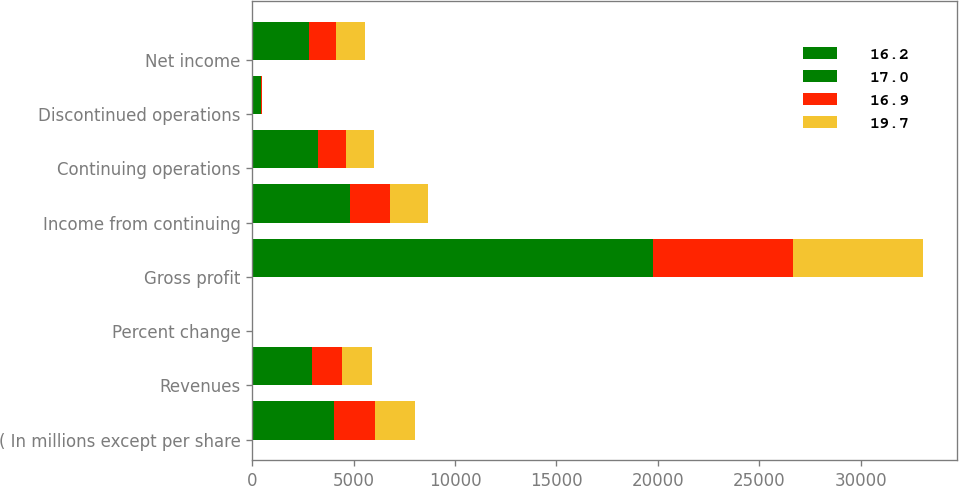<chart> <loc_0><loc_0><loc_500><loc_500><stacked_bar_chart><ecel><fcel>( In millions except per share<fcel>Revenues<fcel>Percent change<fcel>Gross profit<fcel>Income from continuing<fcel>Continuing operations<fcel>Discontinued operations<fcel>Net income<nl><fcel>16.2<fcel>2015<fcel>1478.5<fcel>30.3<fcel>11411<fcel>2657<fcel>1842<fcel>299<fcel>1543<nl><fcel>17<fcel>2014<fcel>1478.5<fcel>12.4<fcel>8352<fcel>2171<fcel>1414<fcel>156<fcel>1258<nl><fcel>16.9<fcel>2013<fcel>1478.5<fcel>0.2<fcel>6881<fcel>1950<fcel>1363<fcel>25<fcel>1338<nl><fcel>19.7<fcel>2012<fcel>1478.5<fcel>9.5<fcel>6435<fcel>1915<fcel>1394<fcel>9<fcel>1403<nl></chart> 